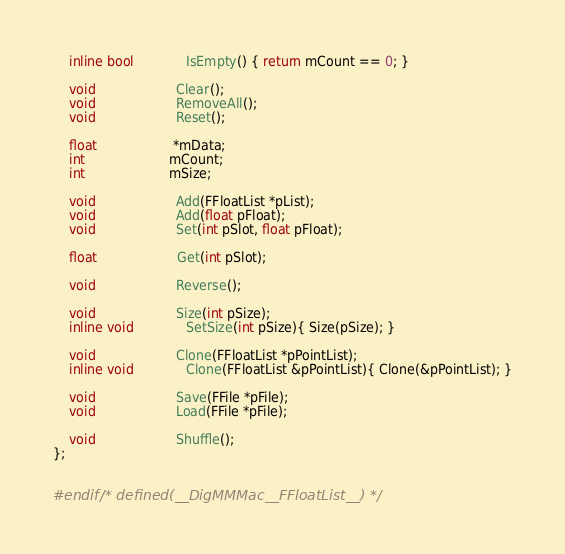<code> <loc_0><loc_0><loc_500><loc_500><_C++_>    inline bool             IsEmpty() { return mCount == 0; }
    
    void                    Clear();
    void                    RemoveAll();
    void                    Reset();
    
    float                   *mData;
    int                     mCount;
    int                     mSize;
    
    void                    Add(FFloatList *pList);
    void                    Add(float pFloat);
    void                    Set(int pSlot, float pFloat);
    
    float	                Get(int pSlot);
    
    void                    Reverse();
    
    void                    Size(int pSize);
    inline void             SetSize(int pSize){ Size(pSize); }
    
    void                    Clone(FFloatList *pPointList);
    inline void             Clone(FFloatList &pPointList){ Clone(&pPointList); }
    
    void                    Save(FFile *pFile);
    void                    Load(FFile *pFile);
    
    void                    Shuffle();
};


#endif /* defined(__DigMMMac__FFloatList__) */
</code> 